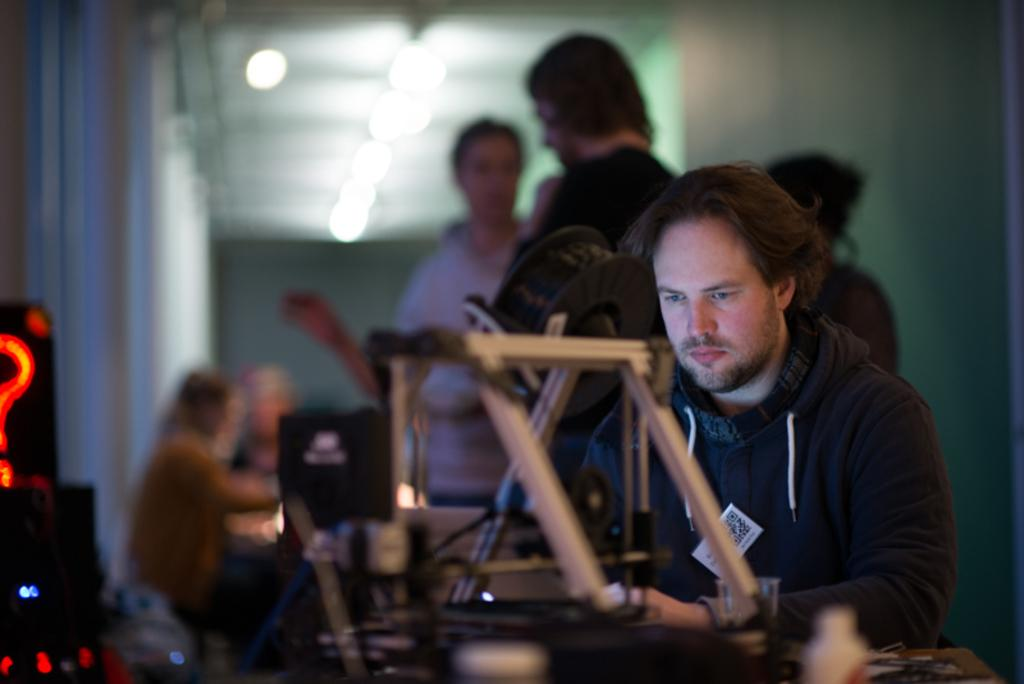What is the main focus of the image? The main focus of the image is the people in the center. Can you describe the lighting in the image? There are lights at the top side of the image. How many ducks are present in the yard in the image? There is no yard or ducks present in the image; it features people and lights. 